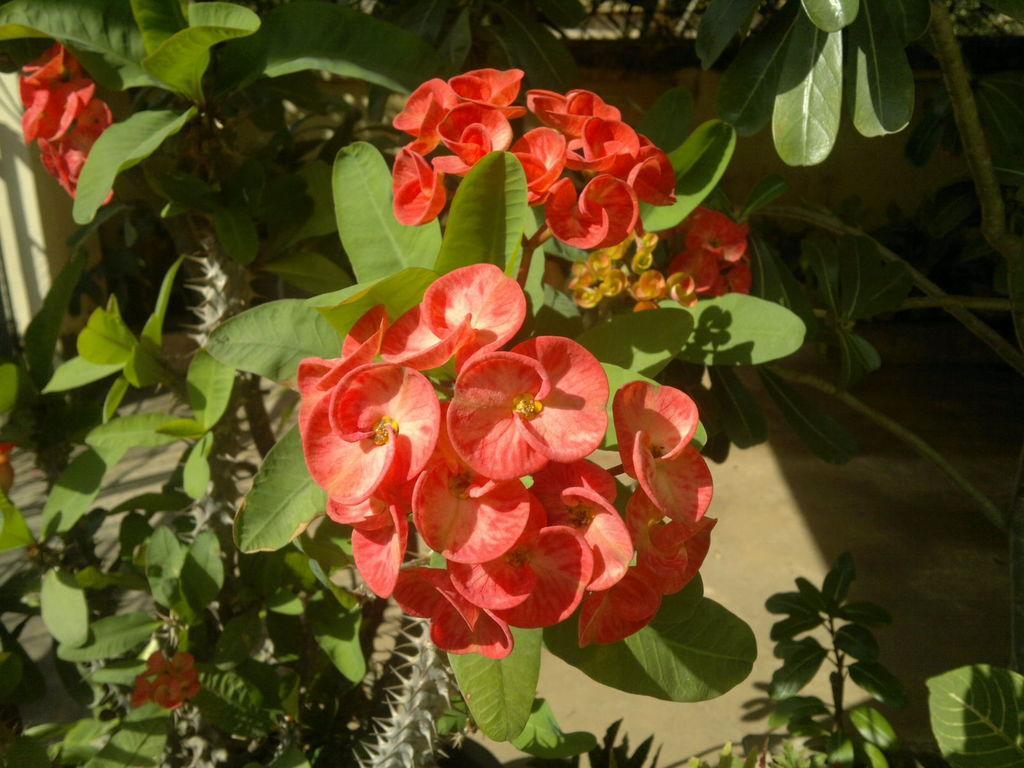Can you describe this image briefly? In the image we can see some flowers and plants. 